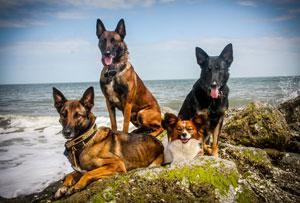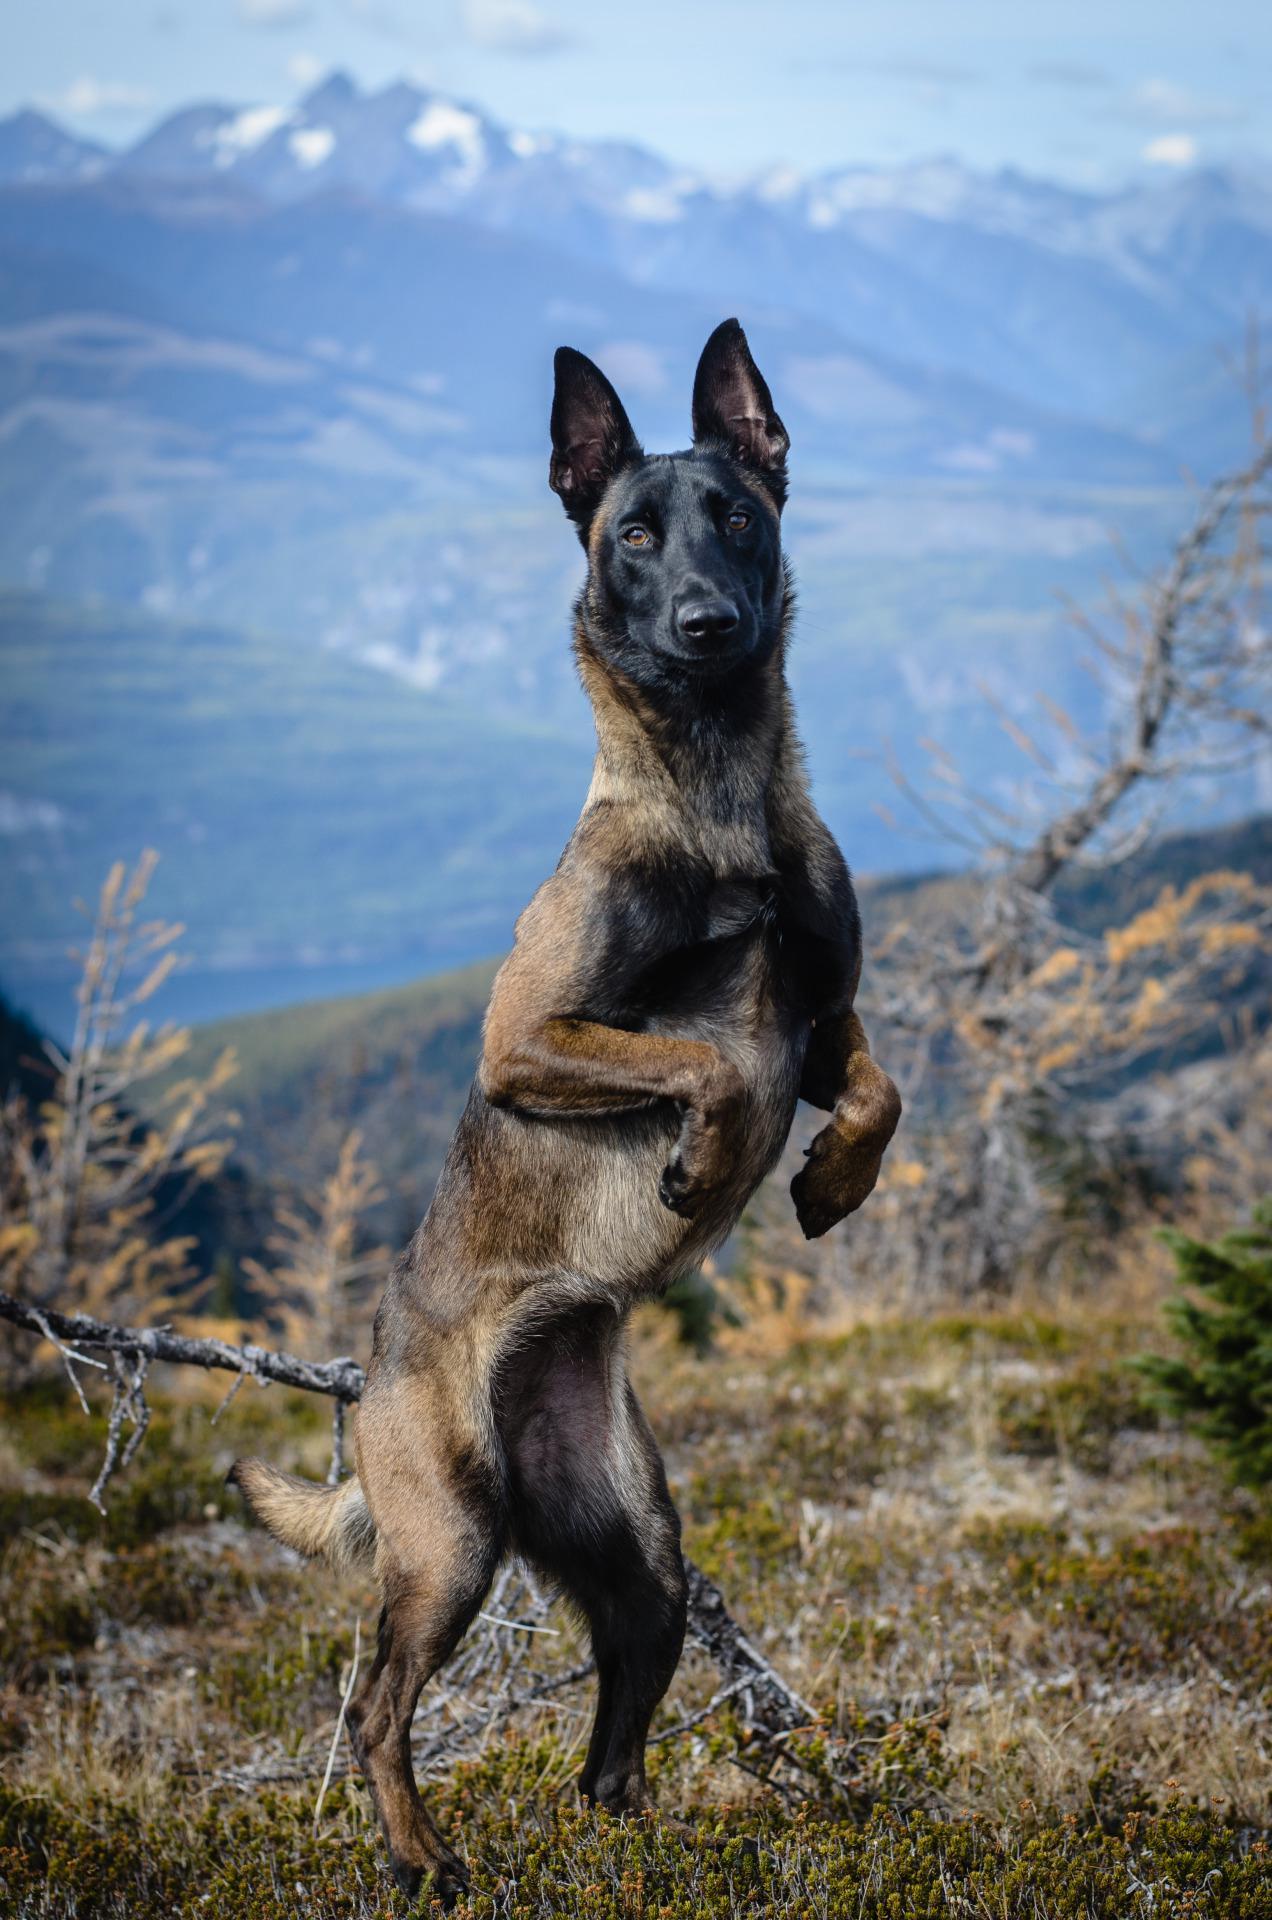The first image is the image on the left, the second image is the image on the right. Evaluate the accuracy of this statement regarding the images: "There are at most four dogs.". Is it true? Answer yes or no. No. The first image is the image on the left, the second image is the image on the right. Given the left and right images, does the statement "The left image includes three german shepherds with tongues out, in reclining poses with front paws extended and flat on the ground." hold true? Answer yes or no. No. 